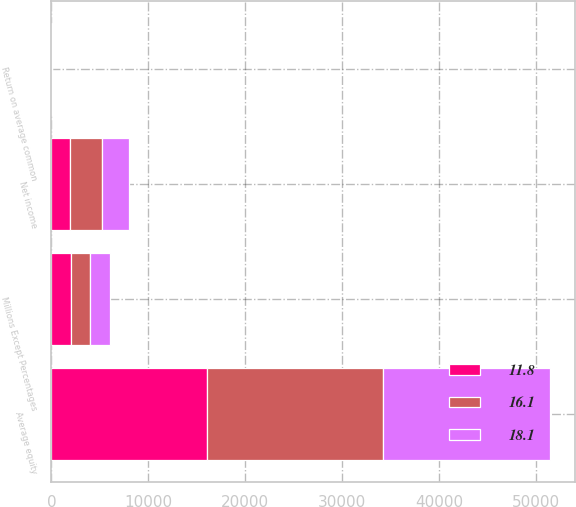Convert chart to OTSL. <chart><loc_0><loc_0><loc_500><loc_500><stacked_bar_chart><ecel><fcel>Millions Except Percentages<fcel>Net income<fcel>Average equity<fcel>Return on average common<nl><fcel>16.1<fcel>2011<fcel>3292<fcel>18171<fcel>18.1<nl><fcel>18.1<fcel>2010<fcel>2780<fcel>17282<fcel>16.1<nl><fcel>11.8<fcel>2009<fcel>1890<fcel>16058<fcel>11.8<nl></chart> 